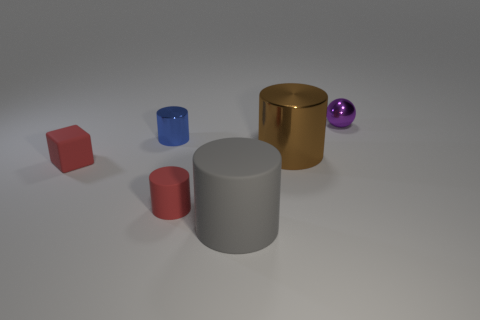Add 3 yellow matte cylinders. How many objects exist? 9 Subtract all blocks. How many objects are left? 5 Add 3 tiny purple metallic things. How many tiny purple metallic things exist? 4 Subtract 0 cyan cubes. How many objects are left? 6 Subtract all purple blocks. Subtract all small purple objects. How many objects are left? 5 Add 3 tiny shiny cylinders. How many tiny shiny cylinders are left? 4 